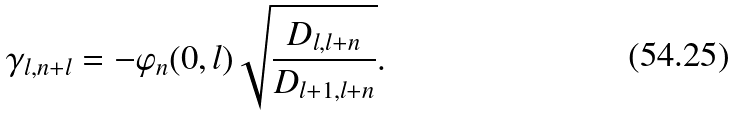Convert formula to latex. <formula><loc_0><loc_0><loc_500><loc_500>\gamma _ { l , n + l } = - \varphi _ { n } ( 0 , l ) \sqrt { \frac { D _ { l , l + n } } { D _ { l + 1 , l + n } } } .</formula> 